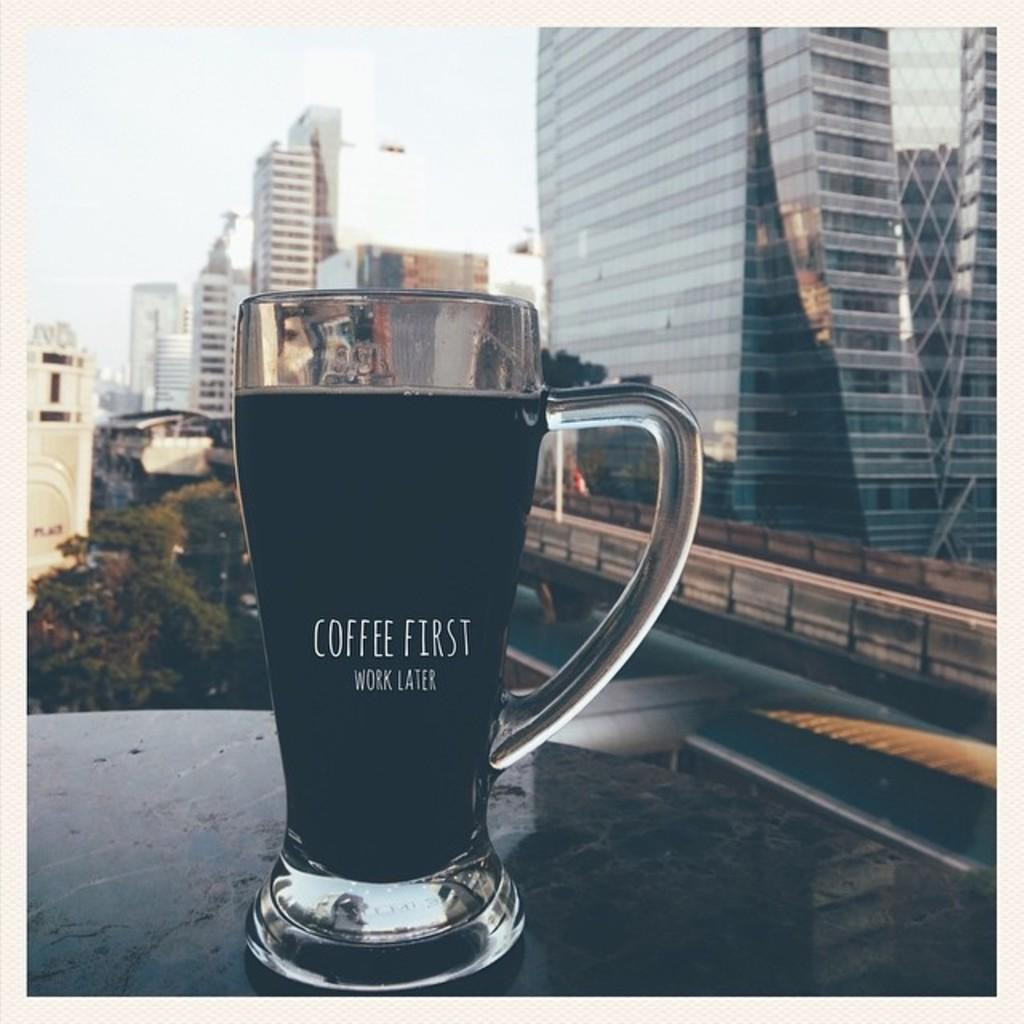Provide a one-sentence caption for the provided image. A cup of coffee that says coffee first work later in front of several buildings. 